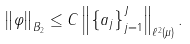Convert formula to latex. <formula><loc_0><loc_0><loc_500><loc_500>\left \| \varphi \right \| _ { B _ { 2 } } \leq C \left \| \left \{ a _ { j } \right \} _ { j = 1 } ^ { J } \right \| _ { \ell ^ { 2 } \left ( \mu \right ) } .</formula> 